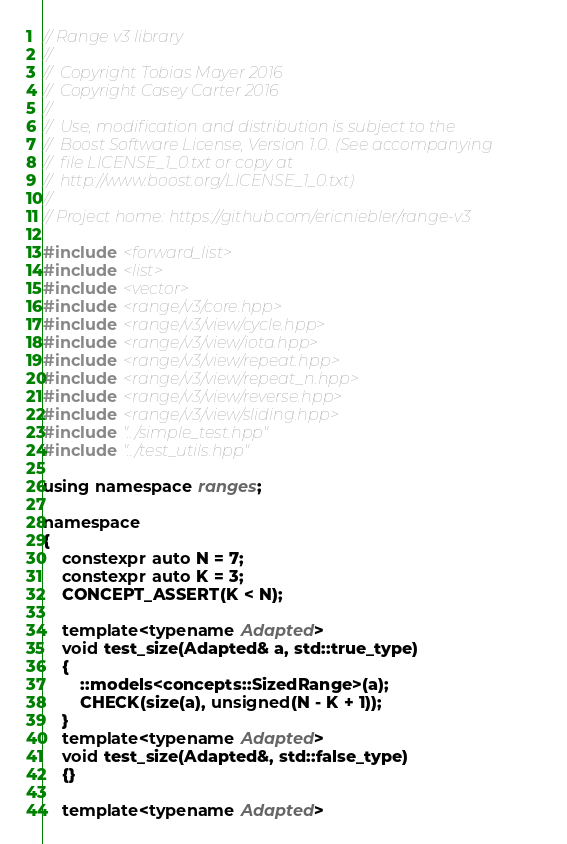Convert code to text. <code><loc_0><loc_0><loc_500><loc_500><_C++_>// Range v3 library
//
//  Copyright Tobias Mayer 2016
//  Copyright Casey Carter 2016
//
//  Use, modification and distribution is subject to the
//  Boost Software License, Version 1.0. (See accompanying
//  file LICENSE_1_0.txt or copy at
//  http://www.boost.org/LICENSE_1_0.txt)
//
// Project home: https://github.com/ericniebler/range-v3

#include <forward_list>
#include <list>
#include <vector>
#include <range/v3/core.hpp>
#include <range/v3/view/cycle.hpp>
#include <range/v3/view/iota.hpp>
#include <range/v3/view/repeat.hpp>
#include <range/v3/view/repeat_n.hpp>
#include <range/v3/view/reverse.hpp>
#include <range/v3/view/sliding.hpp>
#include "../simple_test.hpp"
#include "../test_utils.hpp"

using namespace ranges;

namespace
{
    constexpr auto N = 7;
    constexpr auto K = 3;
    CONCEPT_ASSERT(K < N);

    template<typename Adapted>
    void test_size(Adapted& a, std::true_type)
    {
        ::models<concepts::SizedRange>(a);
        CHECK(size(a), unsigned(N - K + 1));
    }
    template<typename Adapted>
    void test_size(Adapted&, std::false_type)
    {}

    template<typename Adapted></code> 